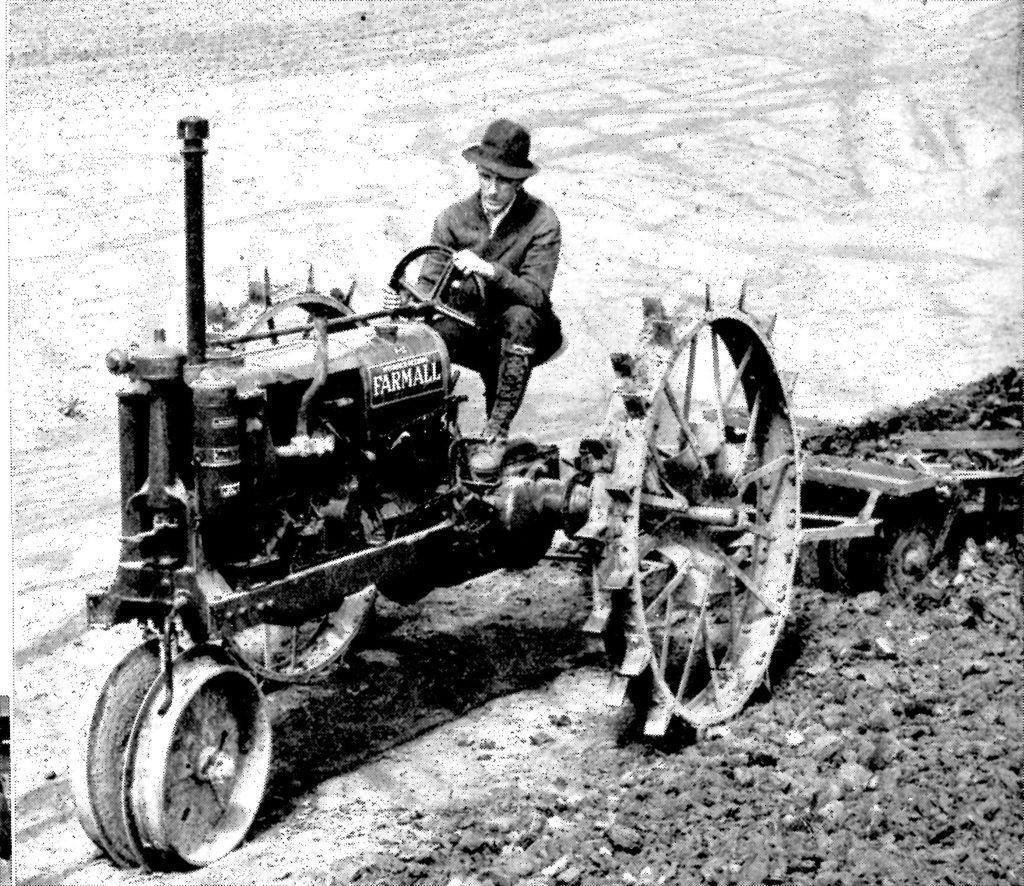Describe this image in one or two sentences. This is a black and white image. Here I can see a man is sitting on the tractor. At the bottom of the image I can see some stones on the ground. 